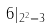<formula> <loc_0><loc_0><loc_500><loc_500>6 | _ { 2 ^ { 2 } = 3 }</formula> 